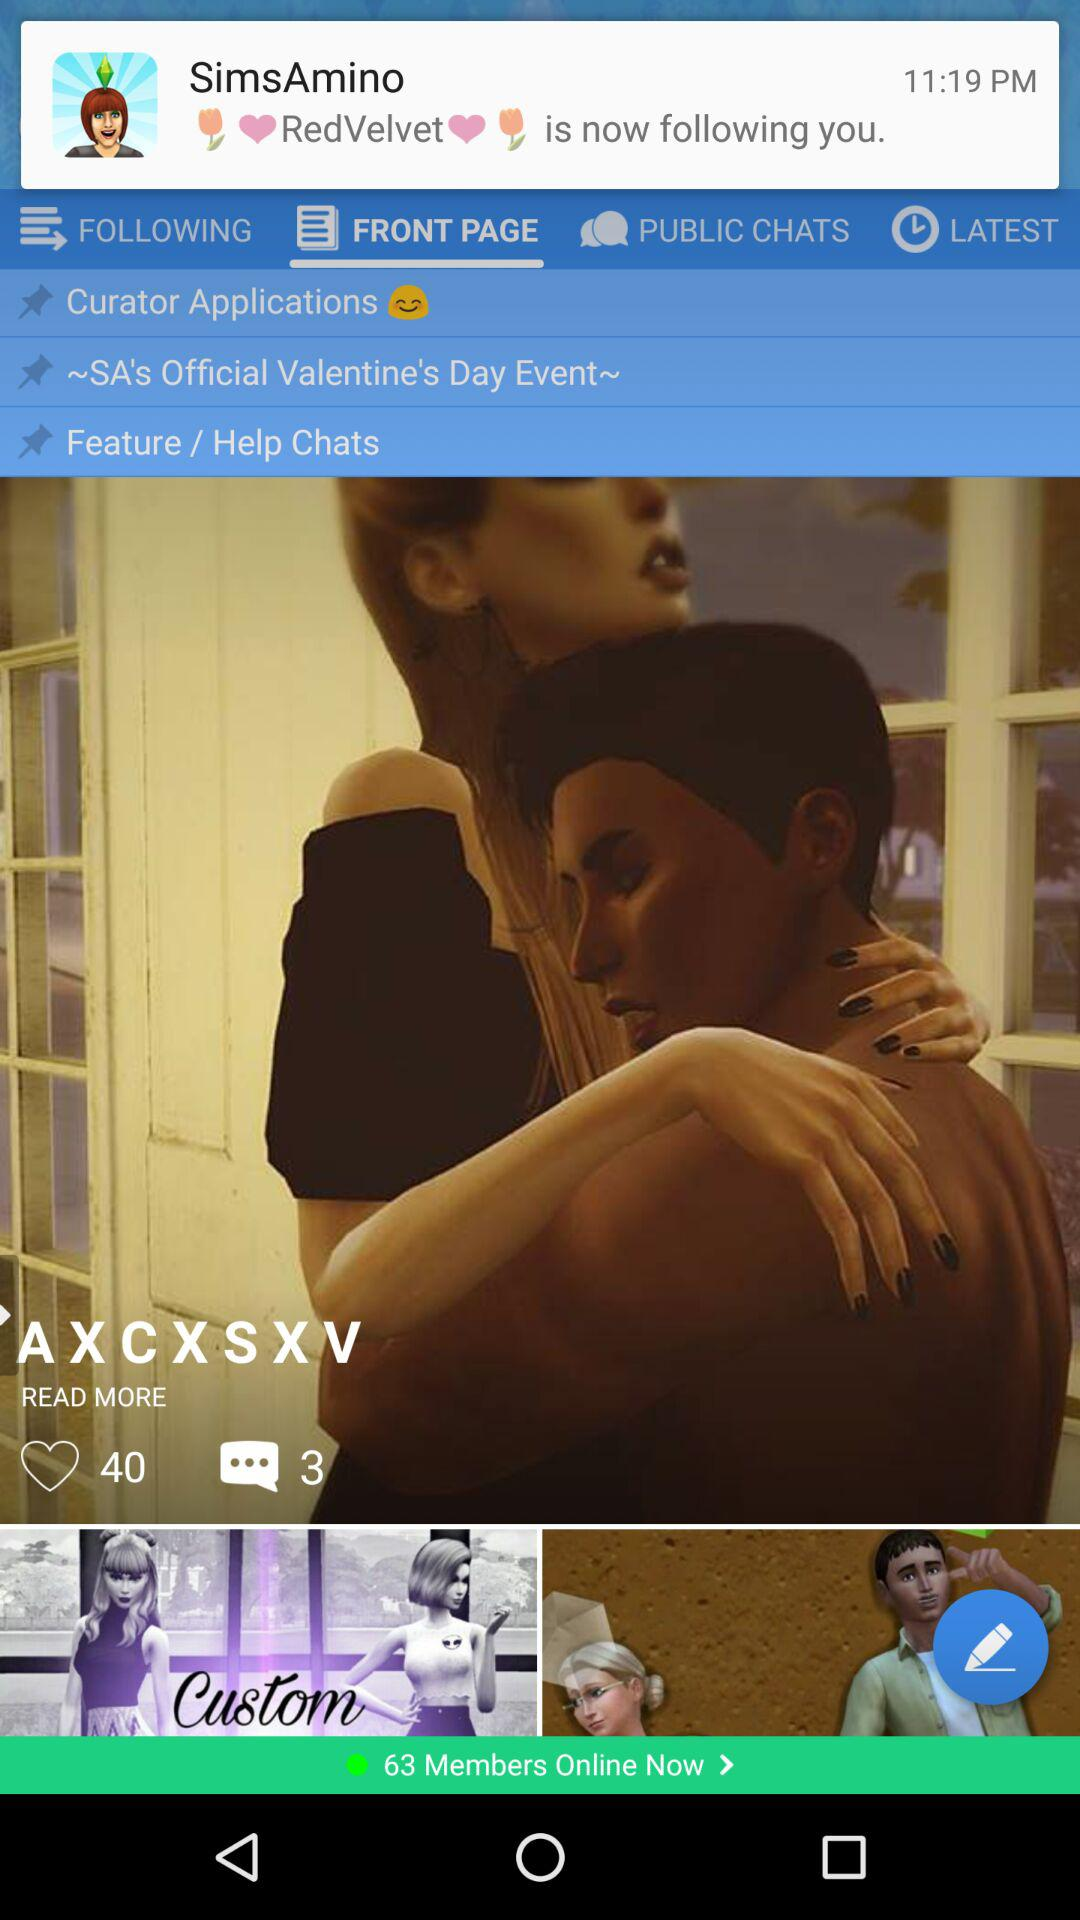How many likes are there on the post? There are 40 likes. 